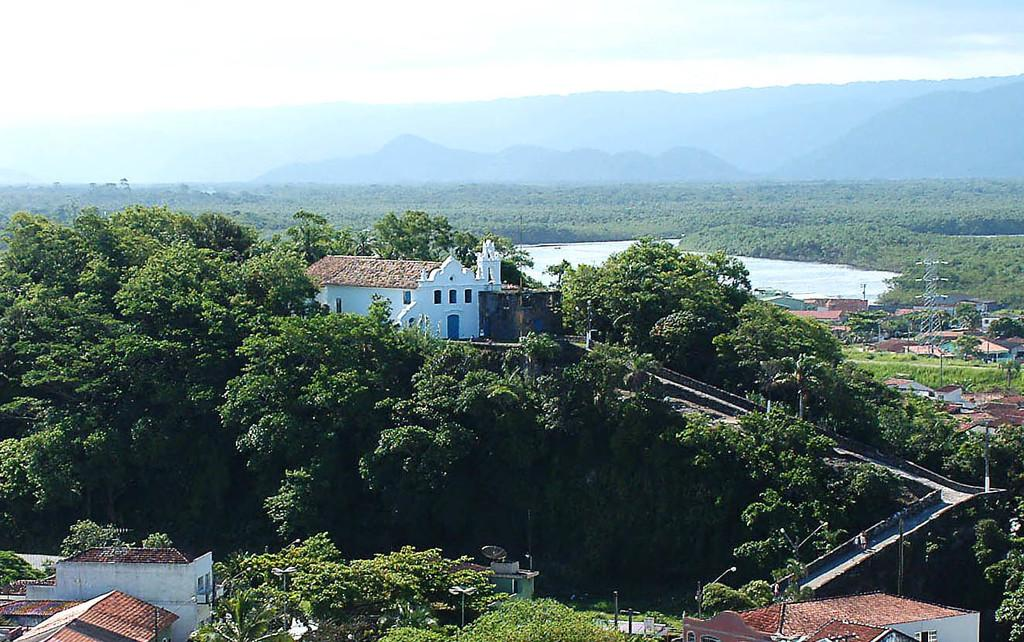What is located in the middle of the image? There are trees, buildings, and poles in the middle of the image. What type of structures can be seen in the image? The image features buildings. What else is present in the middle of the image besides the trees and buildings? There are poles in the middle of the image. What can be seen in the background of the image? Hills are visible at the top of the image, and clouds are present in the sky. Where is the stove located in the image? There is no stove present in the image. What type of wall can be seen in the image? There is no wall present in the image. 